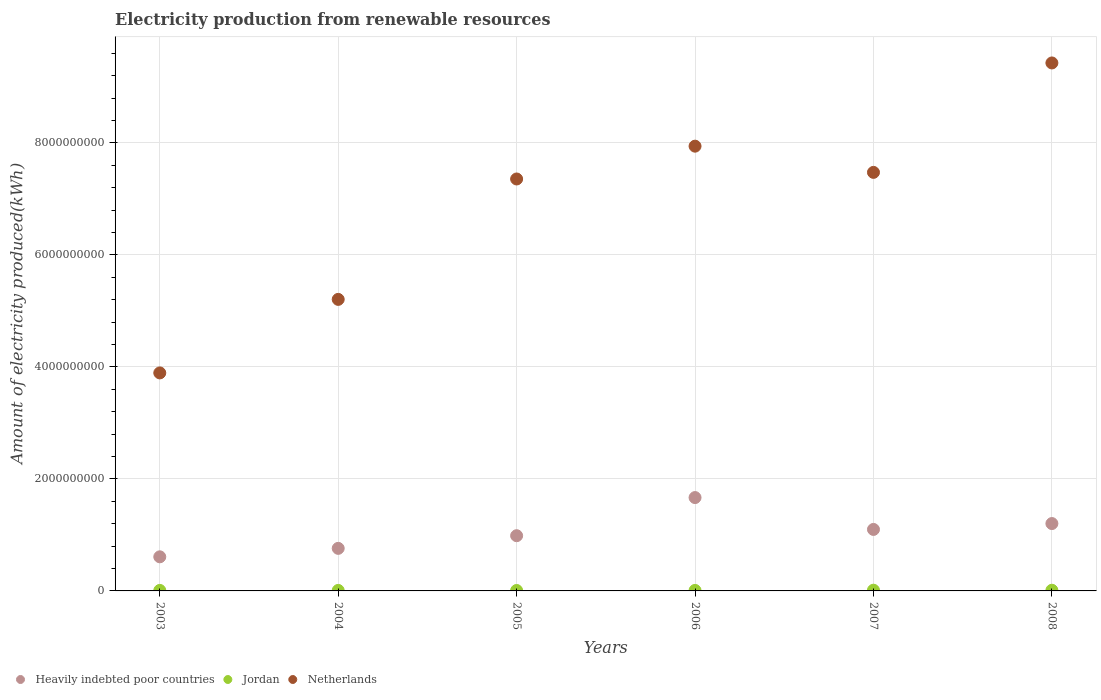What is the amount of electricity produced in Heavily indebted poor countries in 2007?
Offer a terse response. 1.10e+09. Across all years, what is the maximum amount of electricity produced in Heavily indebted poor countries?
Provide a short and direct response. 1.67e+09. Across all years, what is the minimum amount of electricity produced in Heavily indebted poor countries?
Provide a short and direct response. 6.09e+08. What is the total amount of electricity produced in Heavily indebted poor countries in the graph?
Offer a very short reply. 6.32e+09. What is the difference between the amount of electricity produced in Netherlands in 2005 and the amount of electricity produced in Heavily indebted poor countries in 2008?
Ensure brevity in your answer.  6.15e+09. What is the average amount of electricity produced in Heavily indebted poor countries per year?
Your answer should be compact. 1.05e+09. In the year 2008, what is the difference between the amount of electricity produced in Heavily indebted poor countries and amount of electricity produced in Netherlands?
Your answer should be very brief. -8.22e+09. In how many years, is the amount of electricity produced in Heavily indebted poor countries greater than 6800000000 kWh?
Offer a very short reply. 0. Is the amount of electricity produced in Netherlands in 2005 less than that in 2006?
Offer a terse response. Yes. What is the difference between the highest and the second highest amount of electricity produced in Netherlands?
Keep it short and to the point. 1.49e+09. What is the difference between the highest and the lowest amount of electricity produced in Jordan?
Your answer should be compact. 5.00e+06. Is it the case that in every year, the sum of the amount of electricity produced in Netherlands and amount of electricity produced in Jordan  is greater than the amount of electricity produced in Heavily indebted poor countries?
Ensure brevity in your answer.  Yes. Does the amount of electricity produced in Heavily indebted poor countries monotonically increase over the years?
Offer a terse response. No. Is the amount of electricity produced in Heavily indebted poor countries strictly greater than the amount of electricity produced in Netherlands over the years?
Your response must be concise. No. How many dotlines are there?
Your response must be concise. 3. Are the values on the major ticks of Y-axis written in scientific E-notation?
Your response must be concise. No. Does the graph contain any zero values?
Offer a terse response. No. How many legend labels are there?
Your response must be concise. 3. How are the legend labels stacked?
Give a very brief answer. Horizontal. What is the title of the graph?
Offer a terse response. Electricity production from renewable resources. What is the label or title of the Y-axis?
Provide a succinct answer. Amount of electricity produced(kWh). What is the Amount of electricity produced(kWh) of Heavily indebted poor countries in 2003?
Provide a succinct answer. 6.09e+08. What is the Amount of electricity produced(kWh) of Jordan in 2003?
Make the answer very short. 9.00e+06. What is the Amount of electricity produced(kWh) in Netherlands in 2003?
Provide a short and direct response. 3.89e+09. What is the Amount of electricity produced(kWh) of Heavily indebted poor countries in 2004?
Ensure brevity in your answer.  7.60e+08. What is the Amount of electricity produced(kWh) in Jordan in 2004?
Give a very brief answer. 9.00e+06. What is the Amount of electricity produced(kWh) of Netherlands in 2004?
Make the answer very short. 5.21e+09. What is the Amount of electricity produced(kWh) in Heavily indebted poor countries in 2005?
Offer a very short reply. 9.86e+08. What is the Amount of electricity produced(kWh) in Netherlands in 2005?
Your answer should be very brief. 7.36e+09. What is the Amount of electricity produced(kWh) of Heavily indebted poor countries in 2006?
Ensure brevity in your answer.  1.67e+09. What is the Amount of electricity produced(kWh) in Jordan in 2006?
Your answer should be very brief. 9.00e+06. What is the Amount of electricity produced(kWh) in Netherlands in 2006?
Your response must be concise. 7.94e+09. What is the Amount of electricity produced(kWh) of Heavily indebted poor countries in 2007?
Make the answer very short. 1.10e+09. What is the Amount of electricity produced(kWh) in Jordan in 2007?
Keep it short and to the point. 1.30e+07. What is the Amount of electricity produced(kWh) of Netherlands in 2007?
Keep it short and to the point. 7.47e+09. What is the Amount of electricity produced(kWh) of Heavily indebted poor countries in 2008?
Your answer should be compact. 1.20e+09. What is the Amount of electricity produced(kWh) in Netherlands in 2008?
Provide a succinct answer. 9.43e+09. Across all years, what is the maximum Amount of electricity produced(kWh) of Heavily indebted poor countries?
Ensure brevity in your answer.  1.67e+09. Across all years, what is the maximum Amount of electricity produced(kWh) of Jordan?
Provide a succinct answer. 1.30e+07. Across all years, what is the maximum Amount of electricity produced(kWh) in Netherlands?
Your answer should be very brief. 9.43e+09. Across all years, what is the minimum Amount of electricity produced(kWh) in Heavily indebted poor countries?
Make the answer very short. 6.09e+08. Across all years, what is the minimum Amount of electricity produced(kWh) in Netherlands?
Provide a short and direct response. 3.89e+09. What is the total Amount of electricity produced(kWh) of Heavily indebted poor countries in the graph?
Provide a short and direct response. 6.32e+09. What is the total Amount of electricity produced(kWh) in Jordan in the graph?
Your response must be concise. 6.00e+07. What is the total Amount of electricity produced(kWh) of Netherlands in the graph?
Your answer should be very brief. 4.13e+1. What is the difference between the Amount of electricity produced(kWh) in Heavily indebted poor countries in 2003 and that in 2004?
Your response must be concise. -1.51e+08. What is the difference between the Amount of electricity produced(kWh) in Netherlands in 2003 and that in 2004?
Your answer should be compact. -1.31e+09. What is the difference between the Amount of electricity produced(kWh) in Heavily indebted poor countries in 2003 and that in 2005?
Offer a terse response. -3.77e+08. What is the difference between the Amount of electricity produced(kWh) of Jordan in 2003 and that in 2005?
Your response must be concise. 1.00e+06. What is the difference between the Amount of electricity produced(kWh) of Netherlands in 2003 and that in 2005?
Give a very brief answer. -3.46e+09. What is the difference between the Amount of electricity produced(kWh) of Heavily indebted poor countries in 2003 and that in 2006?
Your answer should be very brief. -1.06e+09. What is the difference between the Amount of electricity produced(kWh) in Netherlands in 2003 and that in 2006?
Keep it short and to the point. -4.05e+09. What is the difference between the Amount of electricity produced(kWh) of Heavily indebted poor countries in 2003 and that in 2007?
Your response must be concise. -4.89e+08. What is the difference between the Amount of electricity produced(kWh) in Netherlands in 2003 and that in 2007?
Give a very brief answer. -3.58e+09. What is the difference between the Amount of electricity produced(kWh) in Heavily indebted poor countries in 2003 and that in 2008?
Ensure brevity in your answer.  -5.94e+08. What is the difference between the Amount of electricity produced(kWh) of Jordan in 2003 and that in 2008?
Give a very brief answer. -3.00e+06. What is the difference between the Amount of electricity produced(kWh) of Netherlands in 2003 and that in 2008?
Keep it short and to the point. -5.54e+09. What is the difference between the Amount of electricity produced(kWh) of Heavily indebted poor countries in 2004 and that in 2005?
Your answer should be compact. -2.26e+08. What is the difference between the Amount of electricity produced(kWh) in Netherlands in 2004 and that in 2005?
Give a very brief answer. -2.15e+09. What is the difference between the Amount of electricity produced(kWh) in Heavily indebted poor countries in 2004 and that in 2006?
Make the answer very short. -9.07e+08. What is the difference between the Amount of electricity produced(kWh) in Netherlands in 2004 and that in 2006?
Ensure brevity in your answer.  -2.74e+09. What is the difference between the Amount of electricity produced(kWh) in Heavily indebted poor countries in 2004 and that in 2007?
Make the answer very short. -3.38e+08. What is the difference between the Amount of electricity produced(kWh) in Netherlands in 2004 and that in 2007?
Your answer should be compact. -2.27e+09. What is the difference between the Amount of electricity produced(kWh) of Heavily indebted poor countries in 2004 and that in 2008?
Your response must be concise. -4.43e+08. What is the difference between the Amount of electricity produced(kWh) of Netherlands in 2004 and that in 2008?
Provide a succinct answer. -4.22e+09. What is the difference between the Amount of electricity produced(kWh) in Heavily indebted poor countries in 2005 and that in 2006?
Provide a succinct answer. -6.81e+08. What is the difference between the Amount of electricity produced(kWh) in Jordan in 2005 and that in 2006?
Your answer should be very brief. -1.00e+06. What is the difference between the Amount of electricity produced(kWh) of Netherlands in 2005 and that in 2006?
Provide a short and direct response. -5.86e+08. What is the difference between the Amount of electricity produced(kWh) in Heavily indebted poor countries in 2005 and that in 2007?
Give a very brief answer. -1.12e+08. What is the difference between the Amount of electricity produced(kWh) of Jordan in 2005 and that in 2007?
Your answer should be very brief. -5.00e+06. What is the difference between the Amount of electricity produced(kWh) of Netherlands in 2005 and that in 2007?
Give a very brief answer. -1.18e+08. What is the difference between the Amount of electricity produced(kWh) of Heavily indebted poor countries in 2005 and that in 2008?
Make the answer very short. -2.17e+08. What is the difference between the Amount of electricity produced(kWh) of Netherlands in 2005 and that in 2008?
Provide a succinct answer. -2.07e+09. What is the difference between the Amount of electricity produced(kWh) of Heavily indebted poor countries in 2006 and that in 2007?
Your answer should be very brief. 5.69e+08. What is the difference between the Amount of electricity produced(kWh) in Netherlands in 2006 and that in 2007?
Your response must be concise. 4.68e+08. What is the difference between the Amount of electricity produced(kWh) in Heavily indebted poor countries in 2006 and that in 2008?
Offer a terse response. 4.64e+08. What is the difference between the Amount of electricity produced(kWh) in Netherlands in 2006 and that in 2008?
Provide a short and direct response. -1.49e+09. What is the difference between the Amount of electricity produced(kWh) of Heavily indebted poor countries in 2007 and that in 2008?
Keep it short and to the point. -1.05e+08. What is the difference between the Amount of electricity produced(kWh) of Netherlands in 2007 and that in 2008?
Keep it short and to the point. -1.95e+09. What is the difference between the Amount of electricity produced(kWh) of Heavily indebted poor countries in 2003 and the Amount of electricity produced(kWh) of Jordan in 2004?
Your answer should be very brief. 6.00e+08. What is the difference between the Amount of electricity produced(kWh) in Heavily indebted poor countries in 2003 and the Amount of electricity produced(kWh) in Netherlands in 2004?
Keep it short and to the point. -4.60e+09. What is the difference between the Amount of electricity produced(kWh) in Jordan in 2003 and the Amount of electricity produced(kWh) in Netherlands in 2004?
Make the answer very short. -5.20e+09. What is the difference between the Amount of electricity produced(kWh) in Heavily indebted poor countries in 2003 and the Amount of electricity produced(kWh) in Jordan in 2005?
Provide a short and direct response. 6.01e+08. What is the difference between the Amount of electricity produced(kWh) of Heavily indebted poor countries in 2003 and the Amount of electricity produced(kWh) of Netherlands in 2005?
Your answer should be compact. -6.75e+09. What is the difference between the Amount of electricity produced(kWh) of Jordan in 2003 and the Amount of electricity produced(kWh) of Netherlands in 2005?
Offer a terse response. -7.35e+09. What is the difference between the Amount of electricity produced(kWh) of Heavily indebted poor countries in 2003 and the Amount of electricity produced(kWh) of Jordan in 2006?
Give a very brief answer. 6.00e+08. What is the difference between the Amount of electricity produced(kWh) of Heavily indebted poor countries in 2003 and the Amount of electricity produced(kWh) of Netherlands in 2006?
Keep it short and to the point. -7.33e+09. What is the difference between the Amount of electricity produced(kWh) in Jordan in 2003 and the Amount of electricity produced(kWh) in Netherlands in 2006?
Offer a terse response. -7.93e+09. What is the difference between the Amount of electricity produced(kWh) in Heavily indebted poor countries in 2003 and the Amount of electricity produced(kWh) in Jordan in 2007?
Provide a succinct answer. 5.96e+08. What is the difference between the Amount of electricity produced(kWh) in Heavily indebted poor countries in 2003 and the Amount of electricity produced(kWh) in Netherlands in 2007?
Your answer should be very brief. -6.86e+09. What is the difference between the Amount of electricity produced(kWh) of Jordan in 2003 and the Amount of electricity produced(kWh) of Netherlands in 2007?
Your answer should be very brief. -7.46e+09. What is the difference between the Amount of electricity produced(kWh) of Heavily indebted poor countries in 2003 and the Amount of electricity produced(kWh) of Jordan in 2008?
Offer a very short reply. 5.97e+08. What is the difference between the Amount of electricity produced(kWh) of Heavily indebted poor countries in 2003 and the Amount of electricity produced(kWh) of Netherlands in 2008?
Provide a short and direct response. -8.82e+09. What is the difference between the Amount of electricity produced(kWh) of Jordan in 2003 and the Amount of electricity produced(kWh) of Netherlands in 2008?
Ensure brevity in your answer.  -9.42e+09. What is the difference between the Amount of electricity produced(kWh) of Heavily indebted poor countries in 2004 and the Amount of electricity produced(kWh) of Jordan in 2005?
Give a very brief answer. 7.52e+08. What is the difference between the Amount of electricity produced(kWh) of Heavily indebted poor countries in 2004 and the Amount of electricity produced(kWh) of Netherlands in 2005?
Offer a terse response. -6.60e+09. What is the difference between the Amount of electricity produced(kWh) in Jordan in 2004 and the Amount of electricity produced(kWh) in Netherlands in 2005?
Make the answer very short. -7.35e+09. What is the difference between the Amount of electricity produced(kWh) of Heavily indebted poor countries in 2004 and the Amount of electricity produced(kWh) of Jordan in 2006?
Give a very brief answer. 7.51e+08. What is the difference between the Amount of electricity produced(kWh) of Heavily indebted poor countries in 2004 and the Amount of electricity produced(kWh) of Netherlands in 2006?
Give a very brief answer. -7.18e+09. What is the difference between the Amount of electricity produced(kWh) in Jordan in 2004 and the Amount of electricity produced(kWh) in Netherlands in 2006?
Ensure brevity in your answer.  -7.93e+09. What is the difference between the Amount of electricity produced(kWh) of Heavily indebted poor countries in 2004 and the Amount of electricity produced(kWh) of Jordan in 2007?
Give a very brief answer. 7.47e+08. What is the difference between the Amount of electricity produced(kWh) of Heavily indebted poor countries in 2004 and the Amount of electricity produced(kWh) of Netherlands in 2007?
Your response must be concise. -6.71e+09. What is the difference between the Amount of electricity produced(kWh) of Jordan in 2004 and the Amount of electricity produced(kWh) of Netherlands in 2007?
Give a very brief answer. -7.46e+09. What is the difference between the Amount of electricity produced(kWh) in Heavily indebted poor countries in 2004 and the Amount of electricity produced(kWh) in Jordan in 2008?
Offer a terse response. 7.48e+08. What is the difference between the Amount of electricity produced(kWh) in Heavily indebted poor countries in 2004 and the Amount of electricity produced(kWh) in Netherlands in 2008?
Provide a short and direct response. -8.67e+09. What is the difference between the Amount of electricity produced(kWh) in Jordan in 2004 and the Amount of electricity produced(kWh) in Netherlands in 2008?
Make the answer very short. -9.42e+09. What is the difference between the Amount of electricity produced(kWh) in Heavily indebted poor countries in 2005 and the Amount of electricity produced(kWh) in Jordan in 2006?
Your answer should be compact. 9.77e+08. What is the difference between the Amount of electricity produced(kWh) in Heavily indebted poor countries in 2005 and the Amount of electricity produced(kWh) in Netherlands in 2006?
Keep it short and to the point. -6.96e+09. What is the difference between the Amount of electricity produced(kWh) of Jordan in 2005 and the Amount of electricity produced(kWh) of Netherlands in 2006?
Your response must be concise. -7.93e+09. What is the difference between the Amount of electricity produced(kWh) of Heavily indebted poor countries in 2005 and the Amount of electricity produced(kWh) of Jordan in 2007?
Your answer should be compact. 9.73e+08. What is the difference between the Amount of electricity produced(kWh) in Heavily indebted poor countries in 2005 and the Amount of electricity produced(kWh) in Netherlands in 2007?
Your answer should be compact. -6.49e+09. What is the difference between the Amount of electricity produced(kWh) in Jordan in 2005 and the Amount of electricity produced(kWh) in Netherlands in 2007?
Your answer should be compact. -7.47e+09. What is the difference between the Amount of electricity produced(kWh) in Heavily indebted poor countries in 2005 and the Amount of electricity produced(kWh) in Jordan in 2008?
Ensure brevity in your answer.  9.74e+08. What is the difference between the Amount of electricity produced(kWh) of Heavily indebted poor countries in 2005 and the Amount of electricity produced(kWh) of Netherlands in 2008?
Your response must be concise. -8.44e+09. What is the difference between the Amount of electricity produced(kWh) of Jordan in 2005 and the Amount of electricity produced(kWh) of Netherlands in 2008?
Provide a short and direct response. -9.42e+09. What is the difference between the Amount of electricity produced(kWh) in Heavily indebted poor countries in 2006 and the Amount of electricity produced(kWh) in Jordan in 2007?
Offer a terse response. 1.65e+09. What is the difference between the Amount of electricity produced(kWh) in Heavily indebted poor countries in 2006 and the Amount of electricity produced(kWh) in Netherlands in 2007?
Provide a succinct answer. -5.81e+09. What is the difference between the Amount of electricity produced(kWh) of Jordan in 2006 and the Amount of electricity produced(kWh) of Netherlands in 2007?
Provide a succinct answer. -7.46e+09. What is the difference between the Amount of electricity produced(kWh) of Heavily indebted poor countries in 2006 and the Amount of electricity produced(kWh) of Jordan in 2008?
Keep it short and to the point. 1.66e+09. What is the difference between the Amount of electricity produced(kWh) in Heavily indebted poor countries in 2006 and the Amount of electricity produced(kWh) in Netherlands in 2008?
Your answer should be very brief. -7.76e+09. What is the difference between the Amount of electricity produced(kWh) in Jordan in 2006 and the Amount of electricity produced(kWh) in Netherlands in 2008?
Your answer should be compact. -9.42e+09. What is the difference between the Amount of electricity produced(kWh) in Heavily indebted poor countries in 2007 and the Amount of electricity produced(kWh) in Jordan in 2008?
Offer a very short reply. 1.09e+09. What is the difference between the Amount of electricity produced(kWh) in Heavily indebted poor countries in 2007 and the Amount of electricity produced(kWh) in Netherlands in 2008?
Offer a terse response. -8.33e+09. What is the difference between the Amount of electricity produced(kWh) of Jordan in 2007 and the Amount of electricity produced(kWh) of Netherlands in 2008?
Offer a terse response. -9.42e+09. What is the average Amount of electricity produced(kWh) of Heavily indebted poor countries per year?
Ensure brevity in your answer.  1.05e+09. What is the average Amount of electricity produced(kWh) of Netherlands per year?
Your answer should be compact. 6.88e+09. In the year 2003, what is the difference between the Amount of electricity produced(kWh) in Heavily indebted poor countries and Amount of electricity produced(kWh) in Jordan?
Make the answer very short. 6.00e+08. In the year 2003, what is the difference between the Amount of electricity produced(kWh) in Heavily indebted poor countries and Amount of electricity produced(kWh) in Netherlands?
Your answer should be very brief. -3.28e+09. In the year 2003, what is the difference between the Amount of electricity produced(kWh) of Jordan and Amount of electricity produced(kWh) of Netherlands?
Keep it short and to the point. -3.88e+09. In the year 2004, what is the difference between the Amount of electricity produced(kWh) in Heavily indebted poor countries and Amount of electricity produced(kWh) in Jordan?
Your response must be concise. 7.51e+08. In the year 2004, what is the difference between the Amount of electricity produced(kWh) in Heavily indebted poor countries and Amount of electricity produced(kWh) in Netherlands?
Ensure brevity in your answer.  -4.45e+09. In the year 2004, what is the difference between the Amount of electricity produced(kWh) of Jordan and Amount of electricity produced(kWh) of Netherlands?
Your answer should be compact. -5.20e+09. In the year 2005, what is the difference between the Amount of electricity produced(kWh) of Heavily indebted poor countries and Amount of electricity produced(kWh) of Jordan?
Your response must be concise. 9.78e+08. In the year 2005, what is the difference between the Amount of electricity produced(kWh) in Heavily indebted poor countries and Amount of electricity produced(kWh) in Netherlands?
Offer a very short reply. -6.37e+09. In the year 2005, what is the difference between the Amount of electricity produced(kWh) in Jordan and Amount of electricity produced(kWh) in Netherlands?
Keep it short and to the point. -7.35e+09. In the year 2006, what is the difference between the Amount of electricity produced(kWh) of Heavily indebted poor countries and Amount of electricity produced(kWh) of Jordan?
Offer a very short reply. 1.66e+09. In the year 2006, what is the difference between the Amount of electricity produced(kWh) in Heavily indebted poor countries and Amount of electricity produced(kWh) in Netherlands?
Your answer should be very brief. -6.28e+09. In the year 2006, what is the difference between the Amount of electricity produced(kWh) in Jordan and Amount of electricity produced(kWh) in Netherlands?
Your response must be concise. -7.93e+09. In the year 2007, what is the difference between the Amount of electricity produced(kWh) in Heavily indebted poor countries and Amount of electricity produced(kWh) in Jordan?
Your answer should be compact. 1.08e+09. In the year 2007, what is the difference between the Amount of electricity produced(kWh) of Heavily indebted poor countries and Amount of electricity produced(kWh) of Netherlands?
Ensure brevity in your answer.  -6.38e+09. In the year 2007, what is the difference between the Amount of electricity produced(kWh) of Jordan and Amount of electricity produced(kWh) of Netherlands?
Make the answer very short. -7.46e+09. In the year 2008, what is the difference between the Amount of electricity produced(kWh) of Heavily indebted poor countries and Amount of electricity produced(kWh) of Jordan?
Your answer should be compact. 1.19e+09. In the year 2008, what is the difference between the Amount of electricity produced(kWh) in Heavily indebted poor countries and Amount of electricity produced(kWh) in Netherlands?
Provide a short and direct response. -8.22e+09. In the year 2008, what is the difference between the Amount of electricity produced(kWh) in Jordan and Amount of electricity produced(kWh) in Netherlands?
Your answer should be very brief. -9.42e+09. What is the ratio of the Amount of electricity produced(kWh) in Heavily indebted poor countries in 2003 to that in 2004?
Offer a very short reply. 0.8. What is the ratio of the Amount of electricity produced(kWh) in Netherlands in 2003 to that in 2004?
Keep it short and to the point. 0.75. What is the ratio of the Amount of electricity produced(kWh) of Heavily indebted poor countries in 2003 to that in 2005?
Provide a short and direct response. 0.62. What is the ratio of the Amount of electricity produced(kWh) in Jordan in 2003 to that in 2005?
Provide a short and direct response. 1.12. What is the ratio of the Amount of electricity produced(kWh) of Netherlands in 2003 to that in 2005?
Give a very brief answer. 0.53. What is the ratio of the Amount of electricity produced(kWh) of Heavily indebted poor countries in 2003 to that in 2006?
Your answer should be very brief. 0.37. What is the ratio of the Amount of electricity produced(kWh) of Netherlands in 2003 to that in 2006?
Your response must be concise. 0.49. What is the ratio of the Amount of electricity produced(kWh) of Heavily indebted poor countries in 2003 to that in 2007?
Provide a succinct answer. 0.55. What is the ratio of the Amount of electricity produced(kWh) of Jordan in 2003 to that in 2007?
Ensure brevity in your answer.  0.69. What is the ratio of the Amount of electricity produced(kWh) in Netherlands in 2003 to that in 2007?
Your answer should be very brief. 0.52. What is the ratio of the Amount of electricity produced(kWh) in Heavily indebted poor countries in 2003 to that in 2008?
Offer a very short reply. 0.51. What is the ratio of the Amount of electricity produced(kWh) in Netherlands in 2003 to that in 2008?
Provide a short and direct response. 0.41. What is the ratio of the Amount of electricity produced(kWh) of Heavily indebted poor countries in 2004 to that in 2005?
Your answer should be very brief. 0.77. What is the ratio of the Amount of electricity produced(kWh) in Jordan in 2004 to that in 2005?
Provide a succinct answer. 1.12. What is the ratio of the Amount of electricity produced(kWh) of Netherlands in 2004 to that in 2005?
Provide a succinct answer. 0.71. What is the ratio of the Amount of electricity produced(kWh) of Heavily indebted poor countries in 2004 to that in 2006?
Provide a short and direct response. 0.46. What is the ratio of the Amount of electricity produced(kWh) in Netherlands in 2004 to that in 2006?
Your answer should be compact. 0.66. What is the ratio of the Amount of electricity produced(kWh) of Heavily indebted poor countries in 2004 to that in 2007?
Offer a terse response. 0.69. What is the ratio of the Amount of electricity produced(kWh) of Jordan in 2004 to that in 2007?
Offer a terse response. 0.69. What is the ratio of the Amount of electricity produced(kWh) of Netherlands in 2004 to that in 2007?
Offer a very short reply. 0.7. What is the ratio of the Amount of electricity produced(kWh) of Heavily indebted poor countries in 2004 to that in 2008?
Offer a very short reply. 0.63. What is the ratio of the Amount of electricity produced(kWh) of Jordan in 2004 to that in 2008?
Give a very brief answer. 0.75. What is the ratio of the Amount of electricity produced(kWh) of Netherlands in 2004 to that in 2008?
Provide a succinct answer. 0.55. What is the ratio of the Amount of electricity produced(kWh) of Heavily indebted poor countries in 2005 to that in 2006?
Give a very brief answer. 0.59. What is the ratio of the Amount of electricity produced(kWh) of Jordan in 2005 to that in 2006?
Offer a terse response. 0.89. What is the ratio of the Amount of electricity produced(kWh) of Netherlands in 2005 to that in 2006?
Your answer should be very brief. 0.93. What is the ratio of the Amount of electricity produced(kWh) in Heavily indebted poor countries in 2005 to that in 2007?
Your answer should be compact. 0.9. What is the ratio of the Amount of electricity produced(kWh) in Jordan in 2005 to that in 2007?
Your answer should be compact. 0.62. What is the ratio of the Amount of electricity produced(kWh) of Netherlands in 2005 to that in 2007?
Ensure brevity in your answer.  0.98. What is the ratio of the Amount of electricity produced(kWh) in Heavily indebted poor countries in 2005 to that in 2008?
Provide a succinct answer. 0.82. What is the ratio of the Amount of electricity produced(kWh) in Jordan in 2005 to that in 2008?
Your answer should be very brief. 0.67. What is the ratio of the Amount of electricity produced(kWh) of Netherlands in 2005 to that in 2008?
Provide a short and direct response. 0.78. What is the ratio of the Amount of electricity produced(kWh) in Heavily indebted poor countries in 2006 to that in 2007?
Offer a terse response. 1.52. What is the ratio of the Amount of electricity produced(kWh) in Jordan in 2006 to that in 2007?
Your response must be concise. 0.69. What is the ratio of the Amount of electricity produced(kWh) of Netherlands in 2006 to that in 2007?
Offer a terse response. 1.06. What is the ratio of the Amount of electricity produced(kWh) in Heavily indebted poor countries in 2006 to that in 2008?
Ensure brevity in your answer.  1.39. What is the ratio of the Amount of electricity produced(kWh) in Jordan in 2006 to that in 2008?
Your answer should be very brief. 0.75. What is the ratio of the Amount of electricity produced(kWh) in Netherlands in 2006 to that in 2008?
Offer a very short reply. 0.84. What is the ratio of the Amount of electricity produced(kWh) in Heavily indebted poor countries in 2007 to that in 2008?
Give a very brief answer. 0.91. What is the ratio of the Amount of electricity produced(kWh) in Netherlands in 2007 to that in 2008?
Your answer should be compact. 0.79. What is the difference between the highest and the second highest Amount of electricity produced(kWh) of Heavily indebted poor countries?
Keep it short and to the point. 4.64e+08. What is the difference between the highest and the second highest Amount of electricity produced(kWh) in Jordan?
Keep it short and to the point. 1.00e+06. What is the difference between the highest and the second highest Amount of electricity produced(kWh) of Netherlands?
Make the answer very short. 1.49e+09. What is the difference between the highest and the lowest Amount of electricity produced(kWh) in Heavily indebted poor countries?
Keep it short and to the point. 1.06e+09. What is the difference between the highest and the lowest Amount of electricity produced(kWh) of Netherlands?
Your response must be concise. 5.54e+09. 